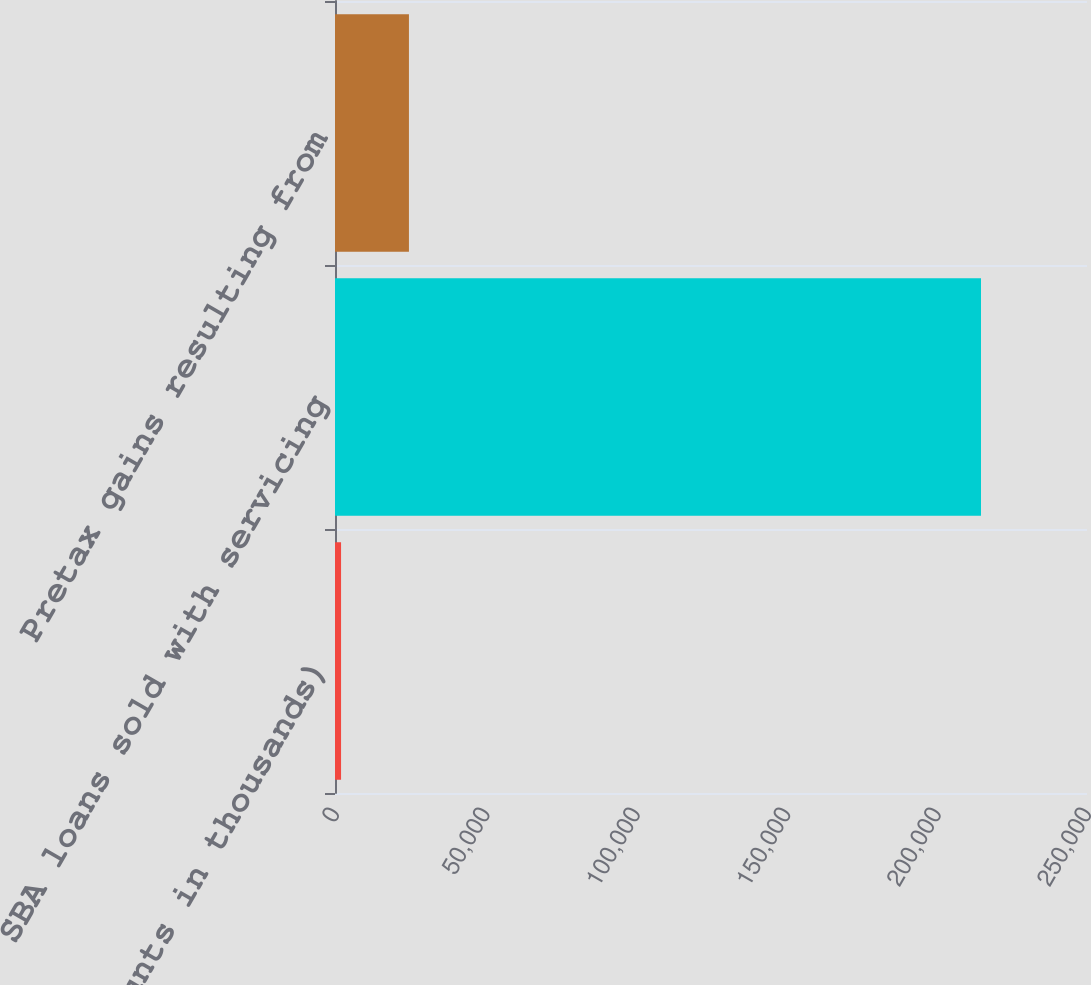<chart> <loc_0><loc_0><loc_500><loc_500><bar_chart><fcel>(dollar amounts in thousands)<fcel>SBA loans sold with servicing<fcel>Pretax gains resulting from<nl><fcel>2014<fcel>214760<fcel>24579<nl></chart> 